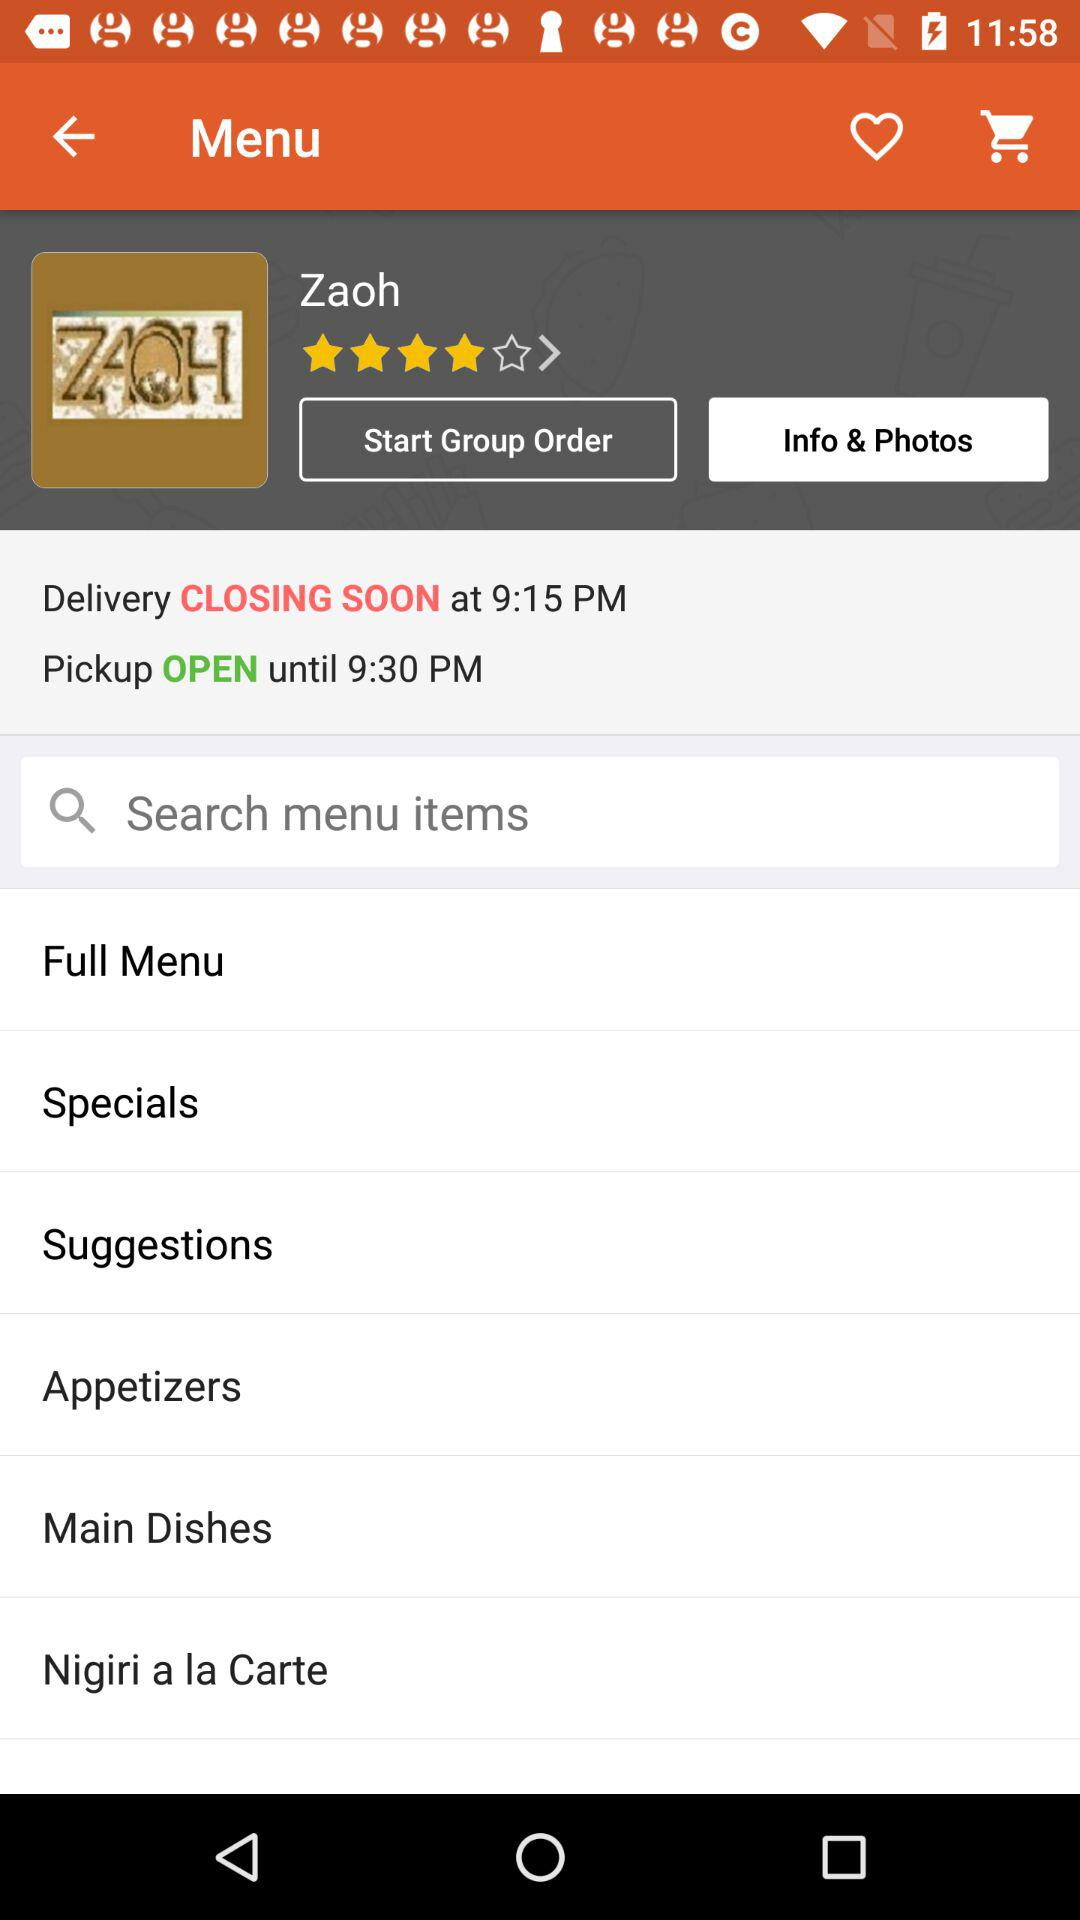How many stars are rated? There are 4 stars rated. 